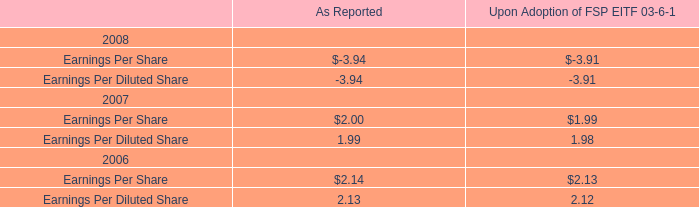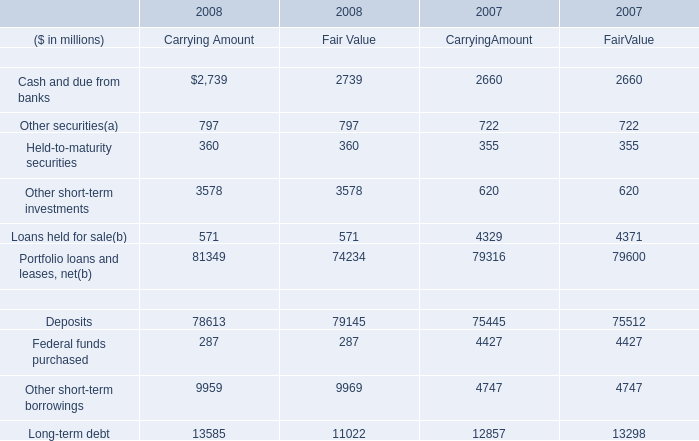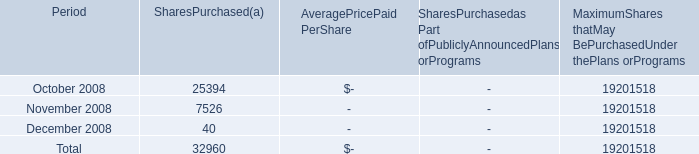In which section the sum of Other securities has the highest value? 
Answer: Carrying Amount and Fair Value in 2008. 